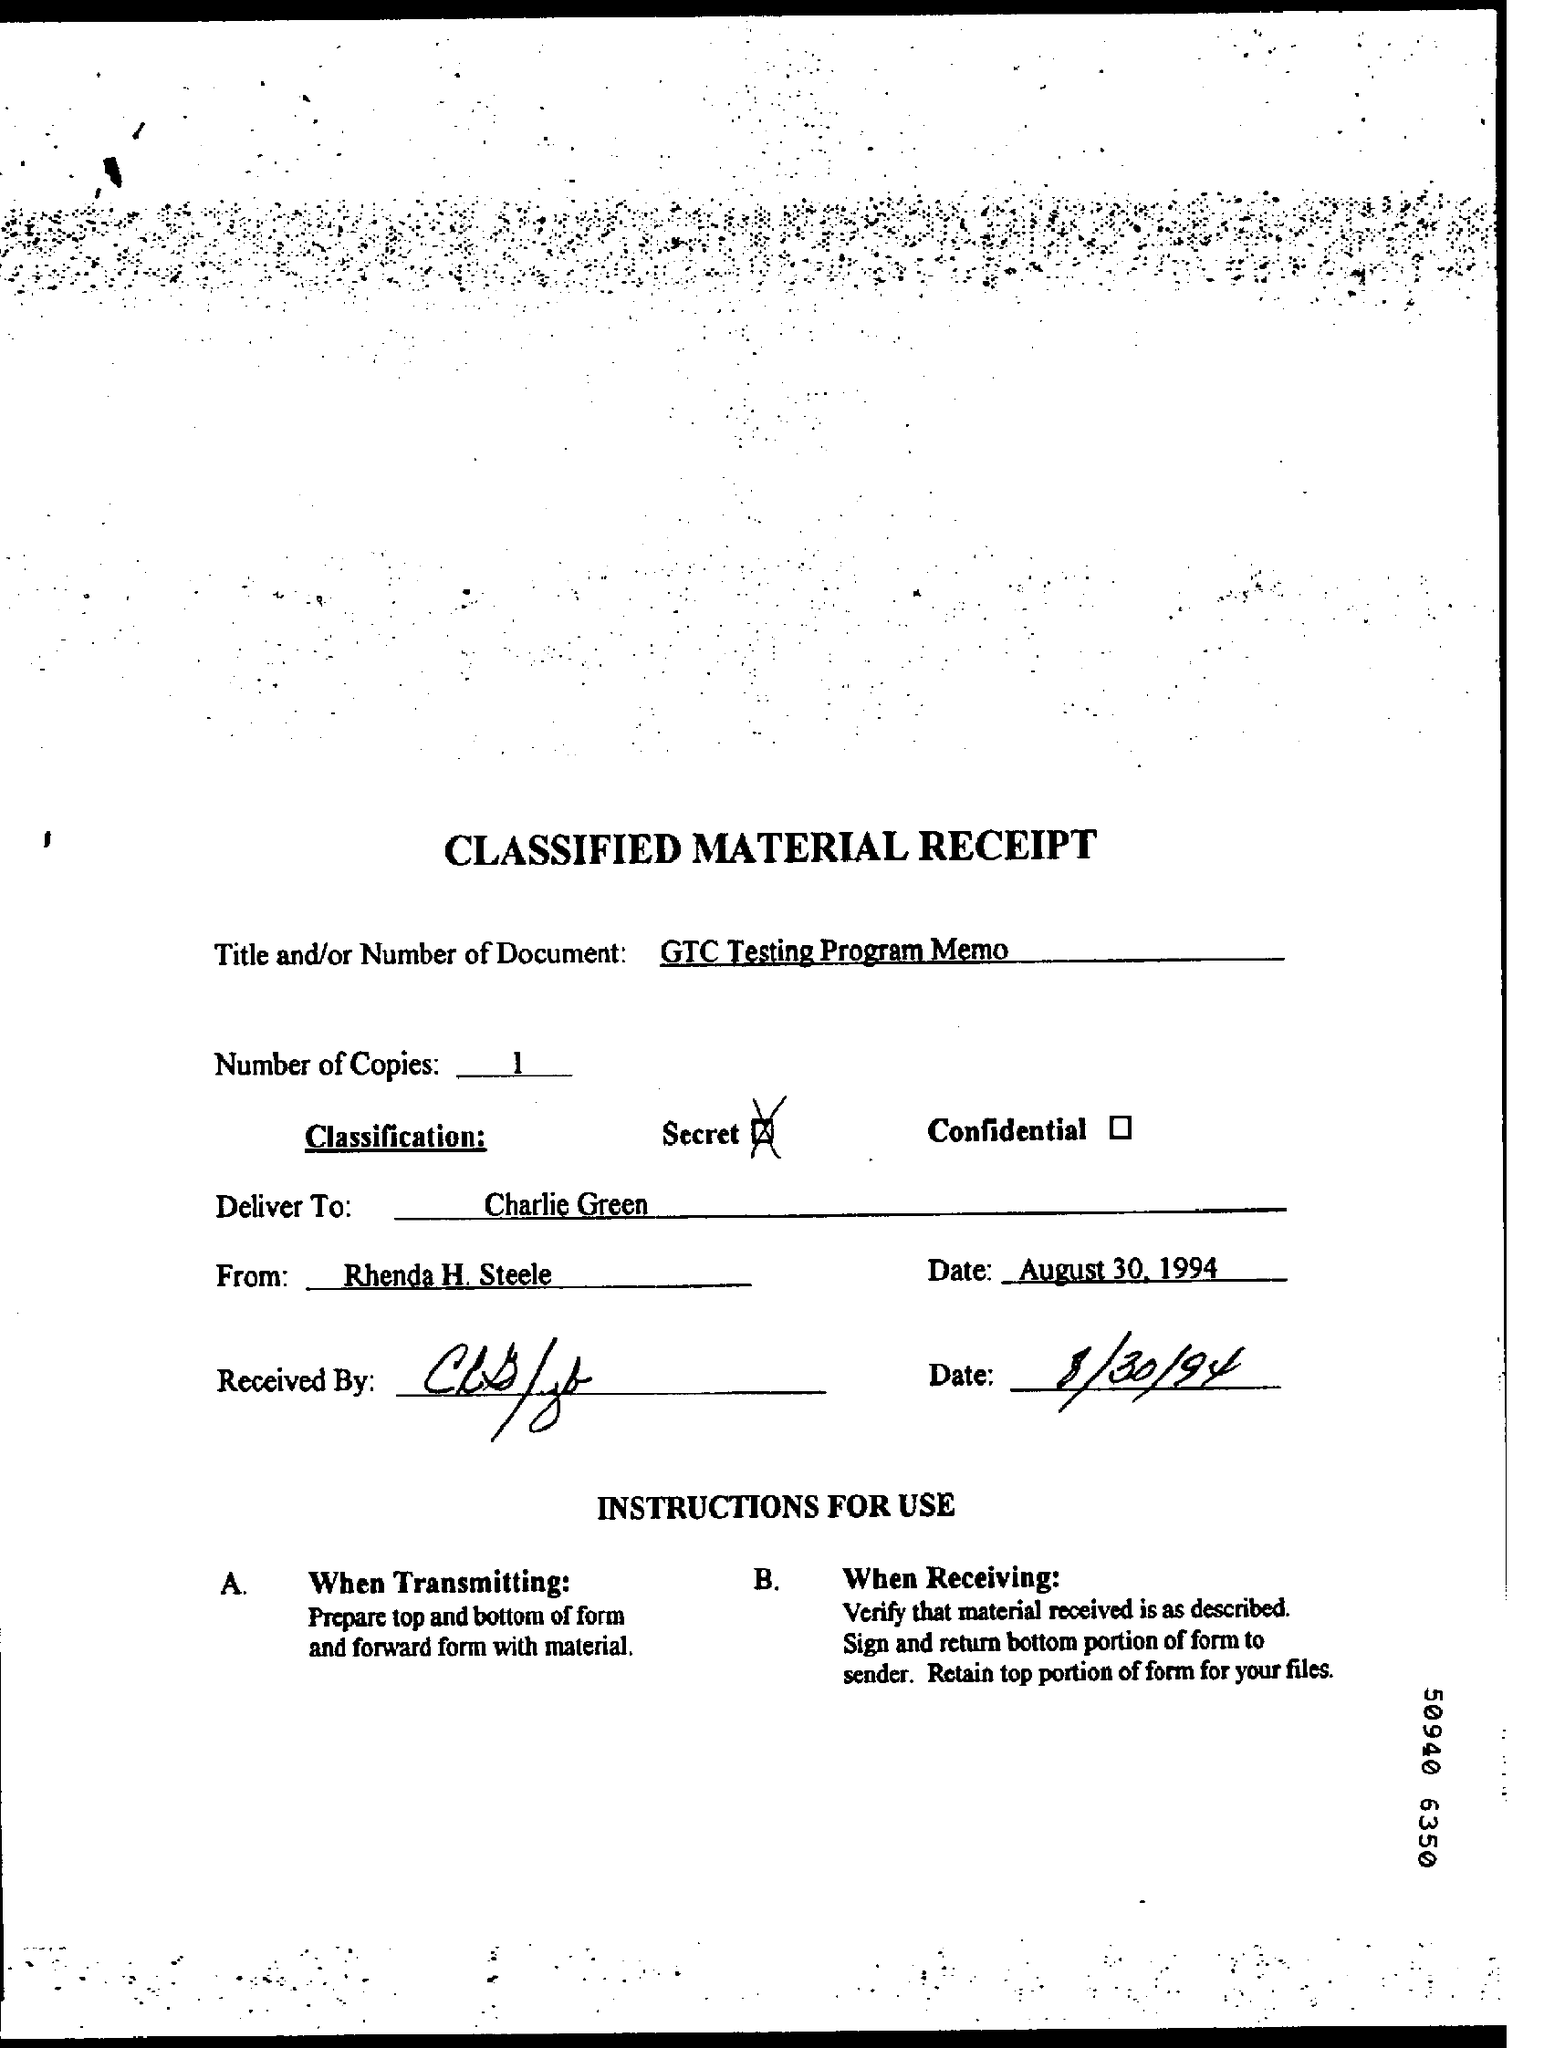What is the title of the document?
Your answer should be compact. GTC Testing Program Memo. How many numbers of copies are mentioned here?
Give a very brief answer. 1. What is the classification mentioned in this document?
Offer a very short reply. Secret. Who is the sender of this document?
Provide a succinct answer. Rhenda H. Steele. 